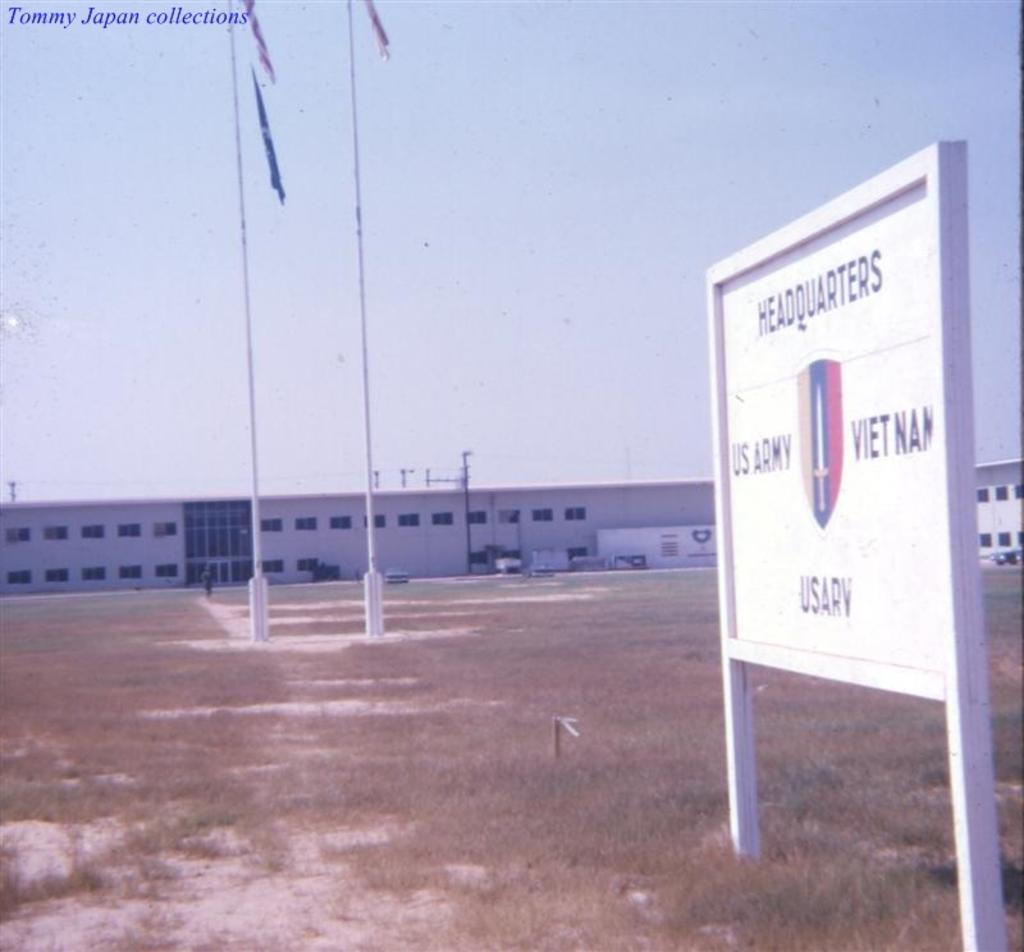What country is this us headquarters in?
Offer a very short reply. Vietnam. 